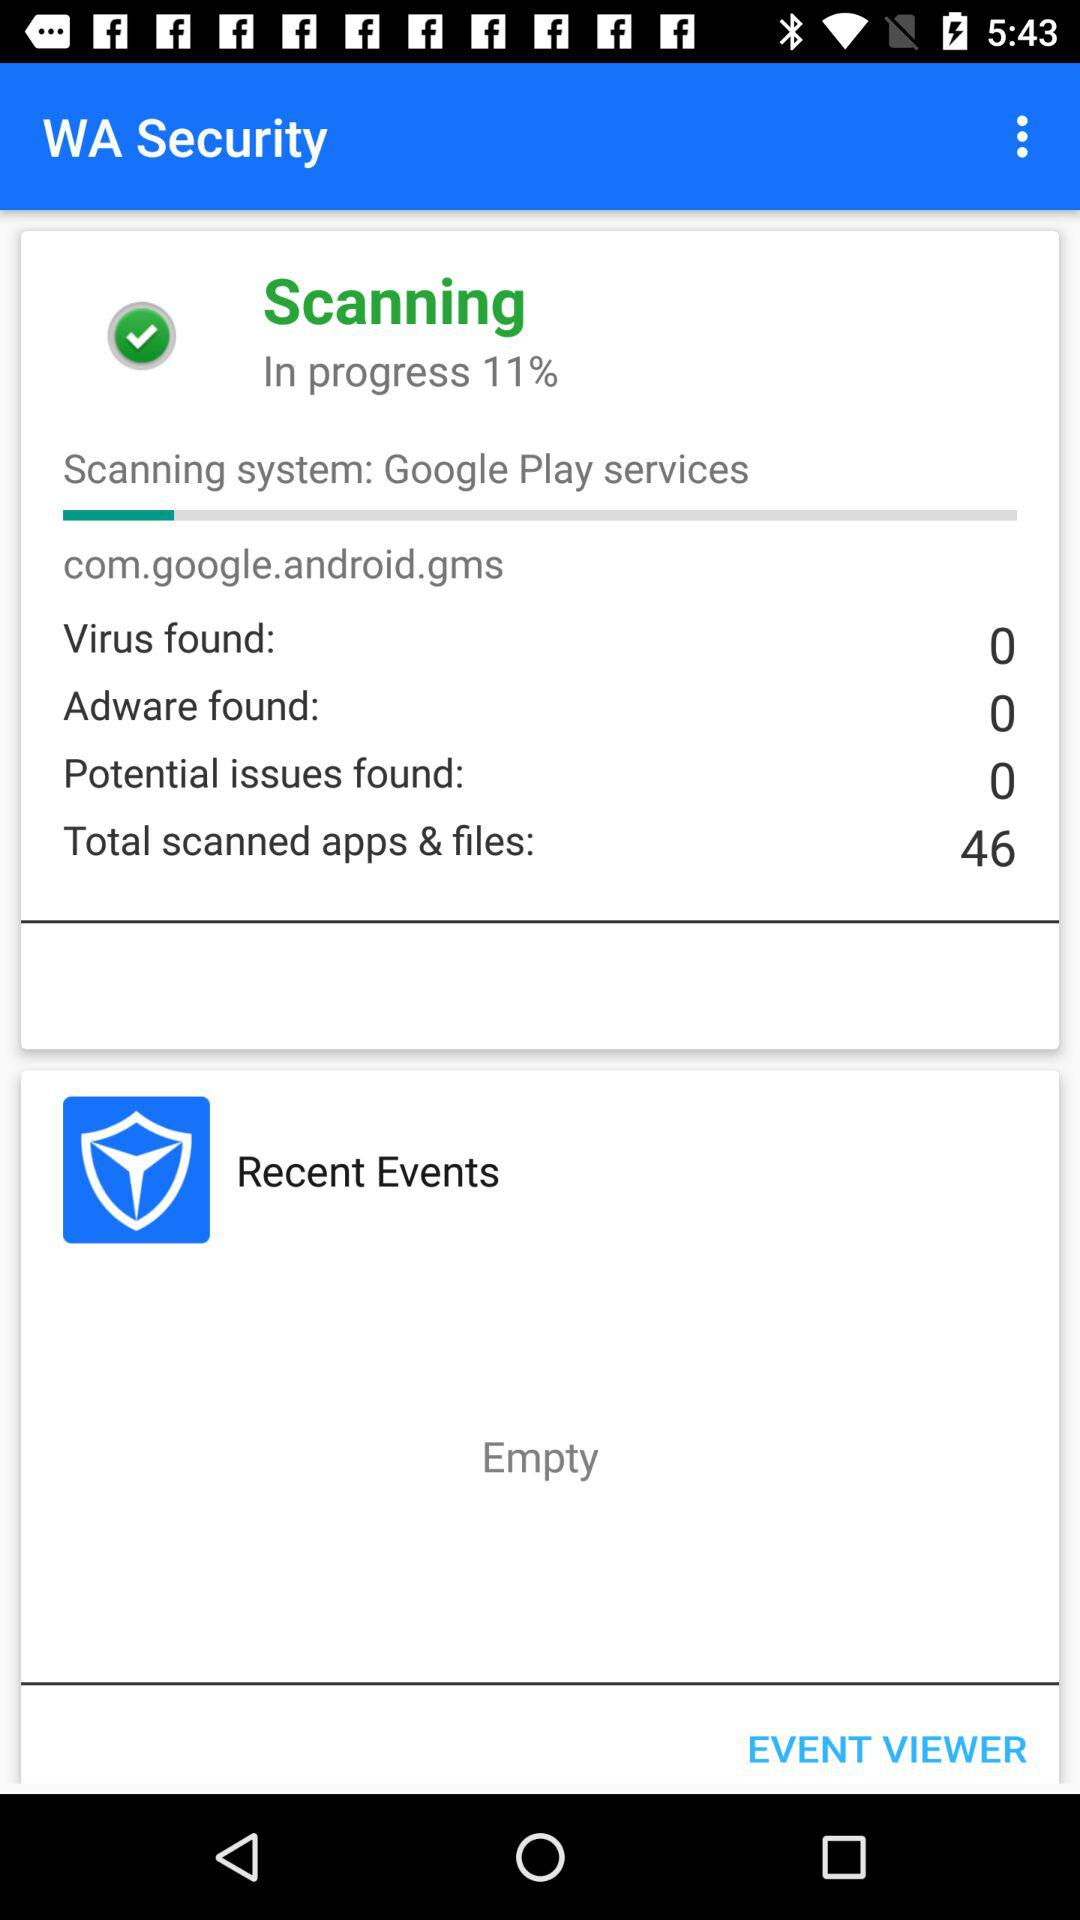How many scanned apps and files are there in total after the scanning is 100% complete?
When the provided information is insufficient, respond with <no answer>. <no answer> 